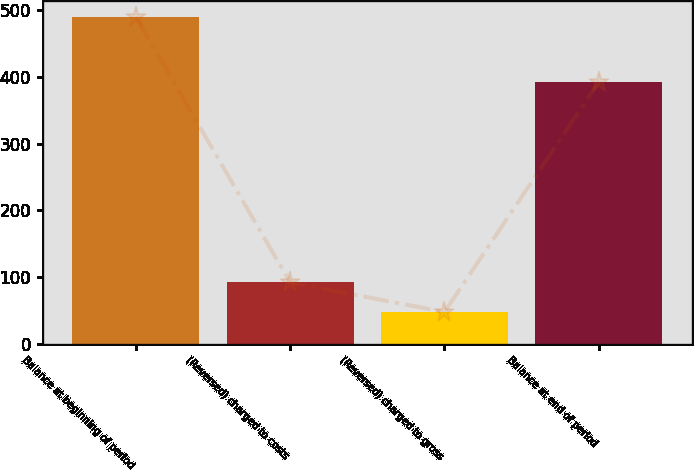Convert chart. <chart><loc_0><loc_0><loc_500><loc_500><bar_chart><fcel>Balance at beginning of period<fcel>(Reversed) charged to costs<fcel>(Reversed) charged to gross<fcel>Balance at end of period<nl><fcel>489.9<fcel>91.74<fcel>47.5<fcel>392.9<nl></chart> 